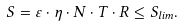<formula> <loc_0><loc_0><loc_500><loc_500>S = \varepsilon \cdot \eta \cdot N \cdot T \cdot R \leq S _ { l i m } .</formula> 